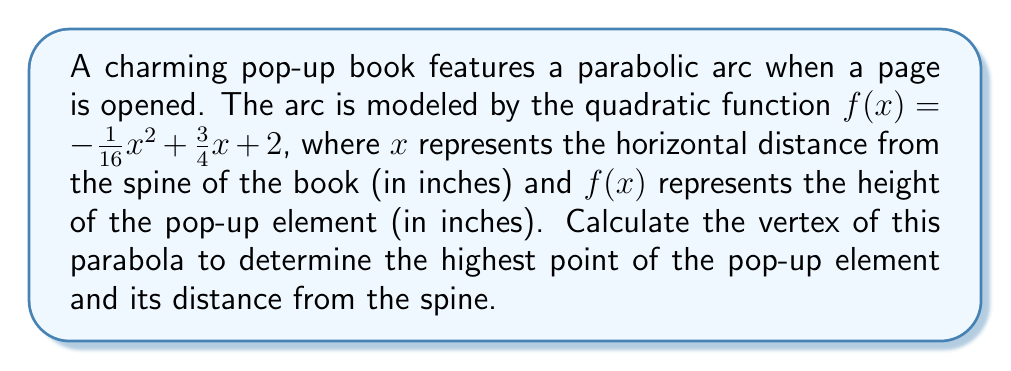Could you help me with this problem? To find the vertex of a parabola given in the form $f(x) = ax^2 + bx + c$, we can use the formula:

$$x = -\frac{b}{2a}$$

Where $a$ and $b$ are the coefficients of $x^2$ and $x$ respectively.

For our function $f(x) = -\frac{1}{16}x^2 + \frac{3}{4}x + 2$:

$a = -\frac{1}{16}$
$b = \frac{3}{4}$

Substituting these values into the formula:

$$x = -\frac{\frac{3}{4}}{2(-\frac{1}{16})} = -\frac{\frac{3}{4}}{-\frac{1}{8}} = \frac{\frac{3}{4}}{\frac{1}{8}} = 6$$

Now that we have the $x$-coordinate of the vertex, we can find the $y$-coordinate by plugging $x = 6$ into our original function:

$$\begin{align*}
f(6) &= -\frac{1}{16}(6)^2 + \frac{3}{4}(6) + 2 \\
&= -\frac{1}{16}(36) + \frac{9}{2} + 2 \\
&= -\frac{9}{4} + \frac{9}{2} + 2 \\
&= -2.25 + 4.5 + 2 \\
&= 4.25
\end{align*}$$

Therefore, the vertex of the parabola is (6, 4.25).
Answer: The vertex of the parabola is (6, 4.25). This means the highest point of the pop-up element is 4.25 inches high and occurs 6 inches from the spine of the book. 